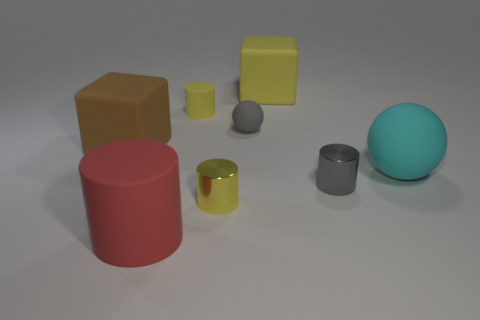Subtract all cyan cubes. How many yellow cylinders are left? 2 Subtract 2 cylinders. How many cylinders are left? 2 Subtract all red cylinders. How many cylinders are left? 3 Subtract all tiny yellow rubber cylinders. How many cylinders are left? 3 Add 1 rubber cubes. How many objects exist? 9 Subtract all purple cylinders. Subtract all green cubes. How many cylinders are left? 4 Subtract all balls. How many objects are left? 6 Subtract 0 green cylinders. How many objects are left? 8 Subtract all small gray balls. Subtract all red rubber objects. How many objects are left? 6 Add 3 small objects. How many small objects are left? 7 